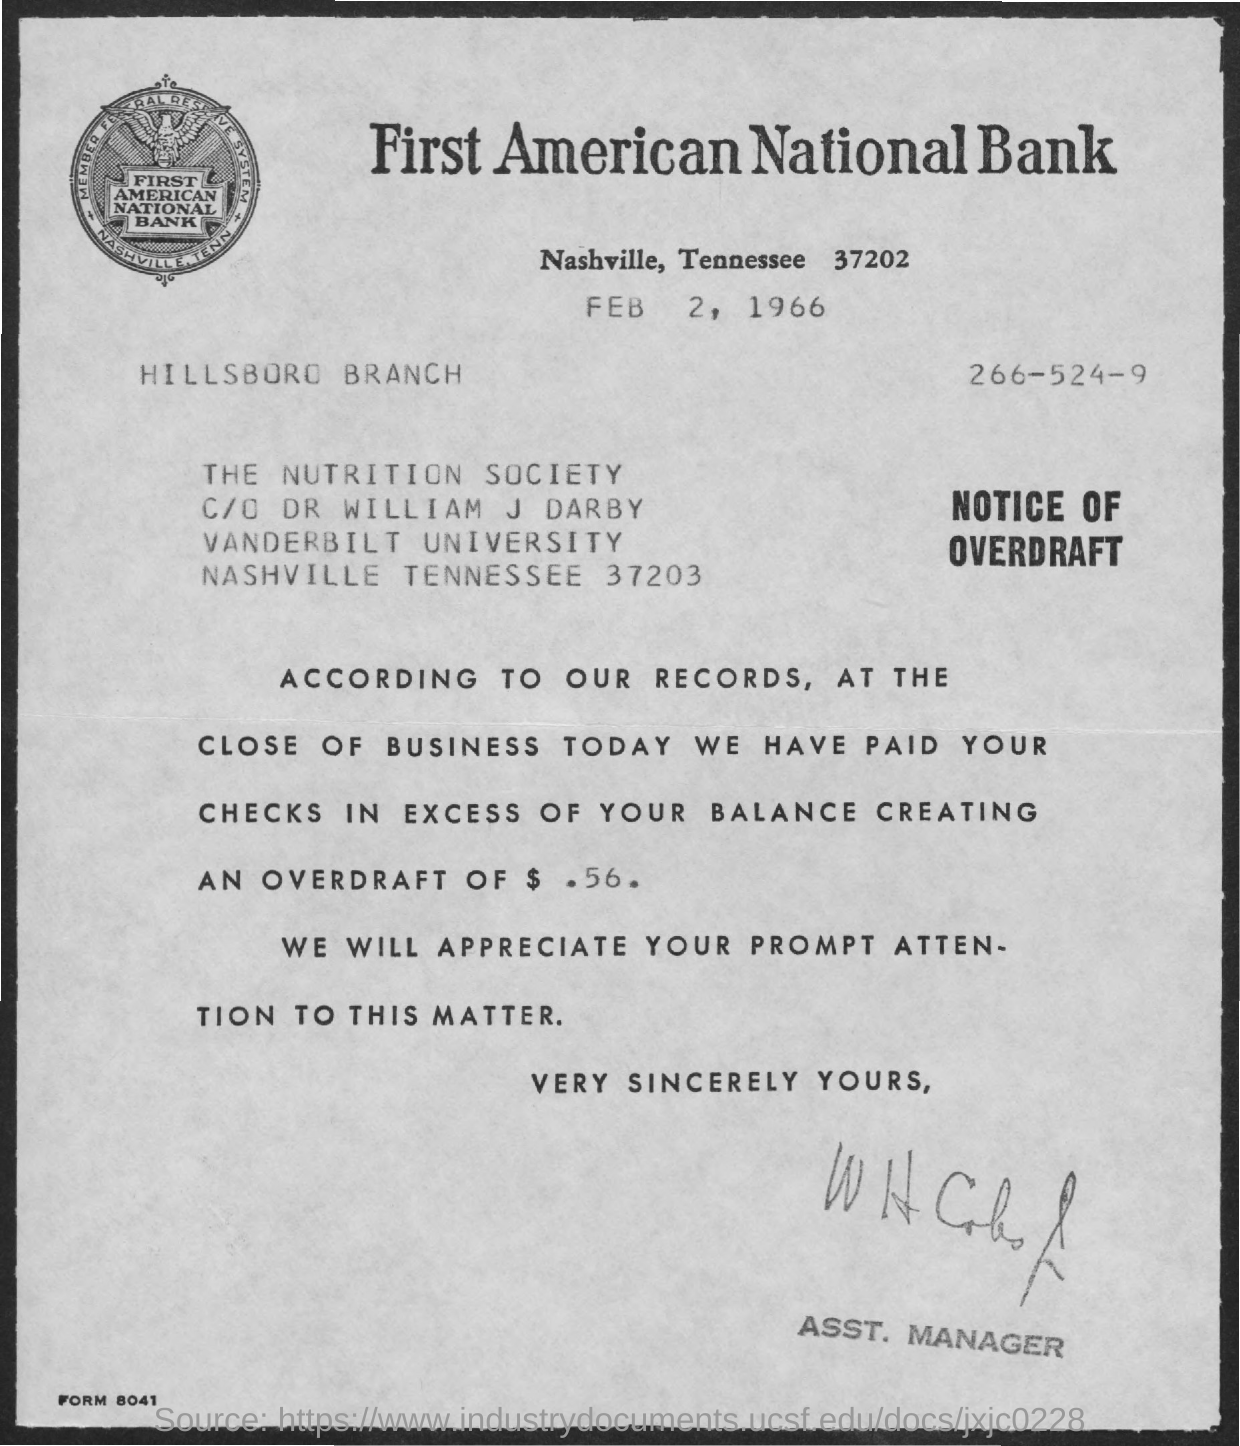Draw attention to some important aspects in this diagram. The letter is addressed to the Nutrition Society. The overdraft currently amounts to $0.56. The document in question bears the date of February 2, 1966. 